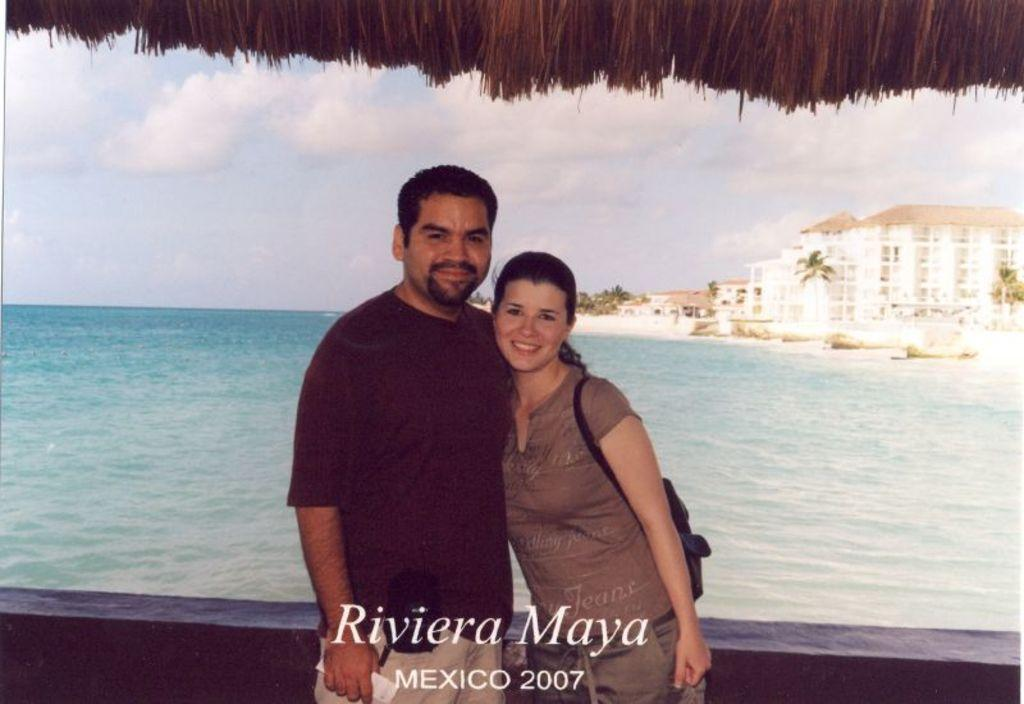How many people are in the image? There are two people standing on a path in the image. What is visible behind the people? Water is visible behind the people. What can be seen in the background of the image? There are buildings, trees, and the sky visible in the background. Is there any indication of the image's origin or ownership? Yes, there is a watermark on the image. What type of pail is being used by the people to compare ideas in the image? There is no pail or indication of idea comparison present in the image. What idea is being discussed by the people in the image? The image does not provide any information about the people's conversation or ideas. 